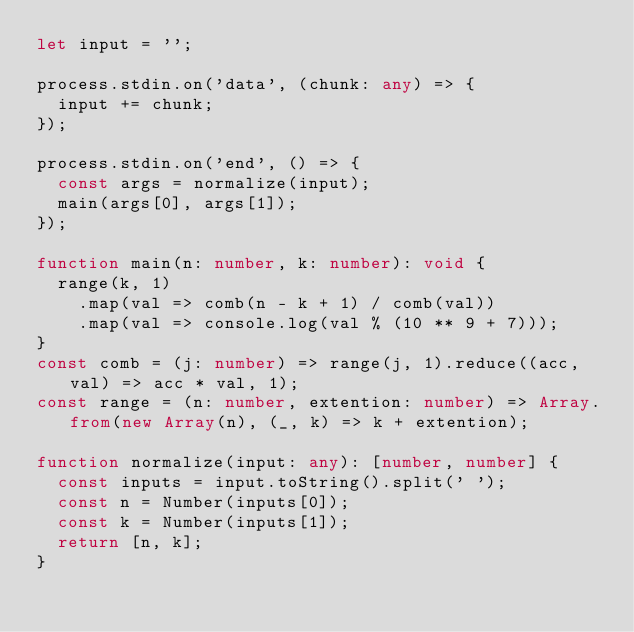Convert code to text. <code><loc_0><loc_0><loc_500><loc_500><_TypeScript_>let input = '';

process.stdin.on('data', (chunk: any) => {
  input += chunk;
});

process.stdin.on('end', () => {
  const args = normalize(input);
  main(args[0], args[1]);
});

function main(n: number, k: number): void {
  range(k, 1)
    .map(val => comb(n - k + 1) / comb(val))
    .map(val => console.log(val % (10 ** 9 + 7)));
}
const comb = (j: number) => range(j, 1).reduce((acc, val) => acc * val, 1);
const range = (n: number, extention: number) => Array.from(new Array(n), (_, k) => k + extention);

function normalize(input: any): [number, number] {
  const inputs = input.toString().split(' ');
  const n = Number(inputs[0]);
  const k = Number(inputs[1]);
  return [n, k];
}
</code> 